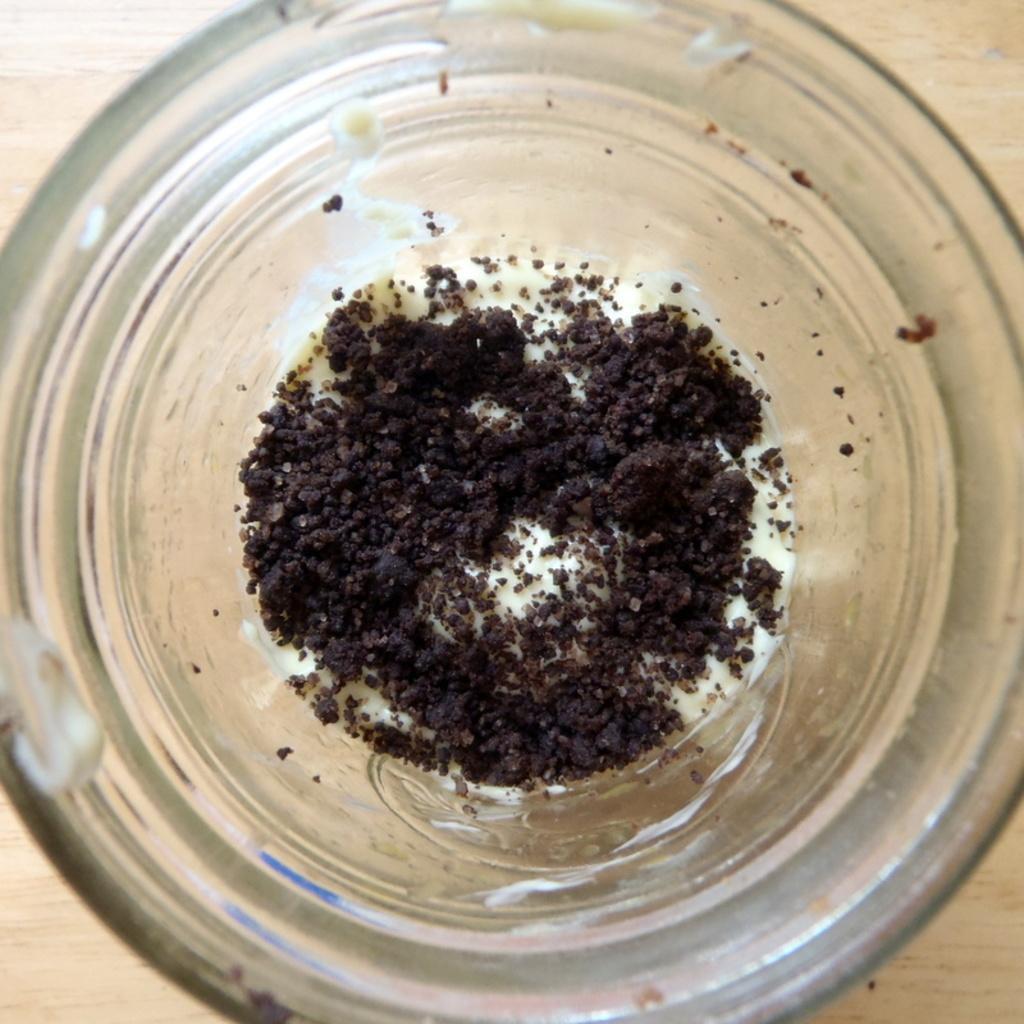In one or two sentences, can you explain what this image depicts? In the center of the image a food item is present in a glass jar. In the background of the image table is there. 